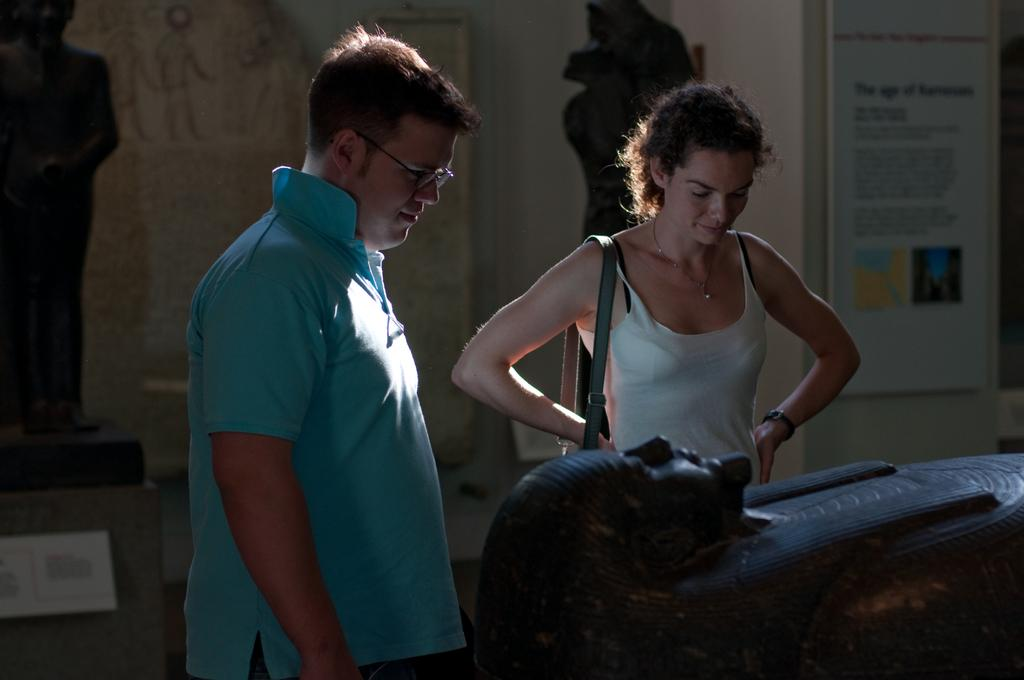What is the man in the image wearing? The man is wearing a blue t-shirt. What is the woman in the image wearing? The woman is wearing a white top. In which direction is the man looking? The man is looking in a specific direction. What type of box can be heard making a sound in the image? There is no box or sound present in the image; it only features a man and a woman. 